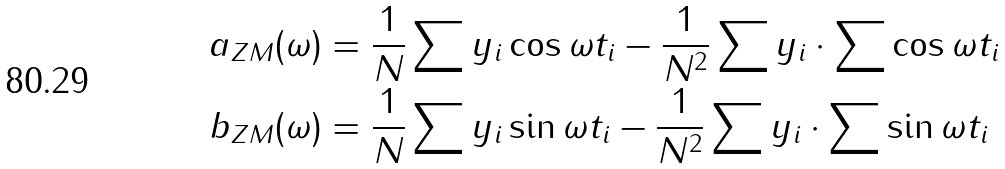Convert formula to latex. <formula><loc_0><loc_0><loc_500><loc_500>a _ { Z M } ( \omega ) & = \frac { 1 } { N } \sum y _ { i } \cos \omega t _ { i } - \frac { 1 } { N ^ { 2 } } \sum y _ { i } \cdot \sum \cos \omega t _ { i } \\ b _ { Z M } ( \omega ) & = \frac { 1 } { N } \sum y _ { i } \sin \omega t _ { i } - \frac { 1 } { N ^ { 2 } } \sum y _ { i } \cdot \sum \sin \omega t _ { i }</formula> 